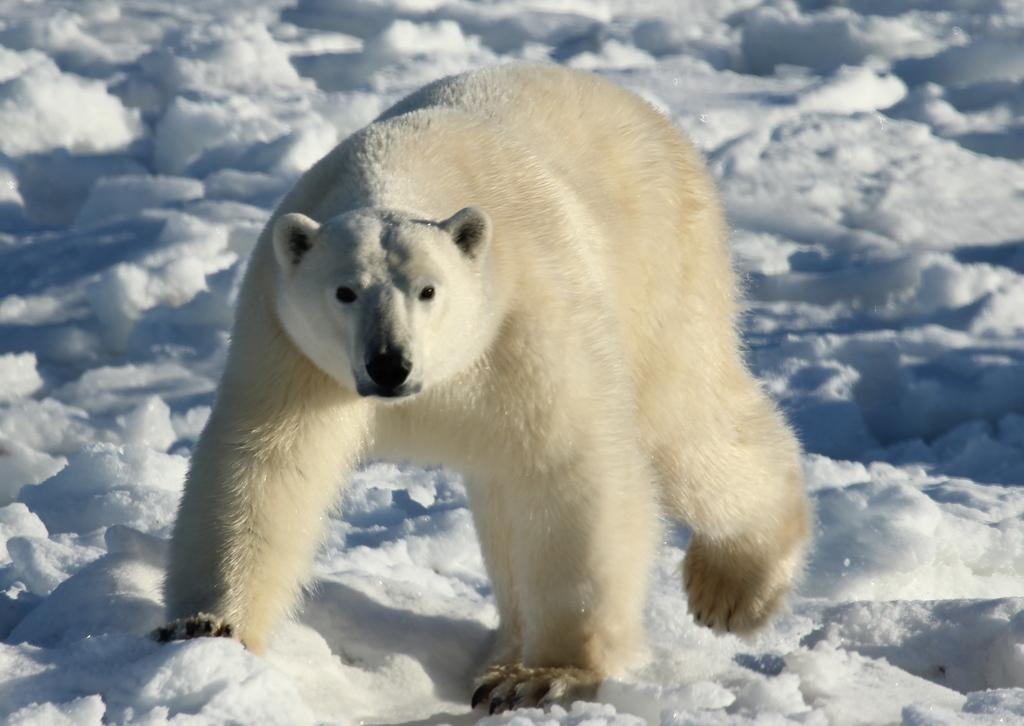What type of weather condition is depicted in the image? There is snow in the image, which suggests a cold or wintry weather condition. What type of animal can be seen in the image? There is a polar bear in the image. What type of disgusting food is being covered by the snow in the image? There is no food present in the image, and therefore no such activity can be observed. Can you tell me how many judges are visible in the image? There are no judges present in the image; it features snow and a polar bear. 